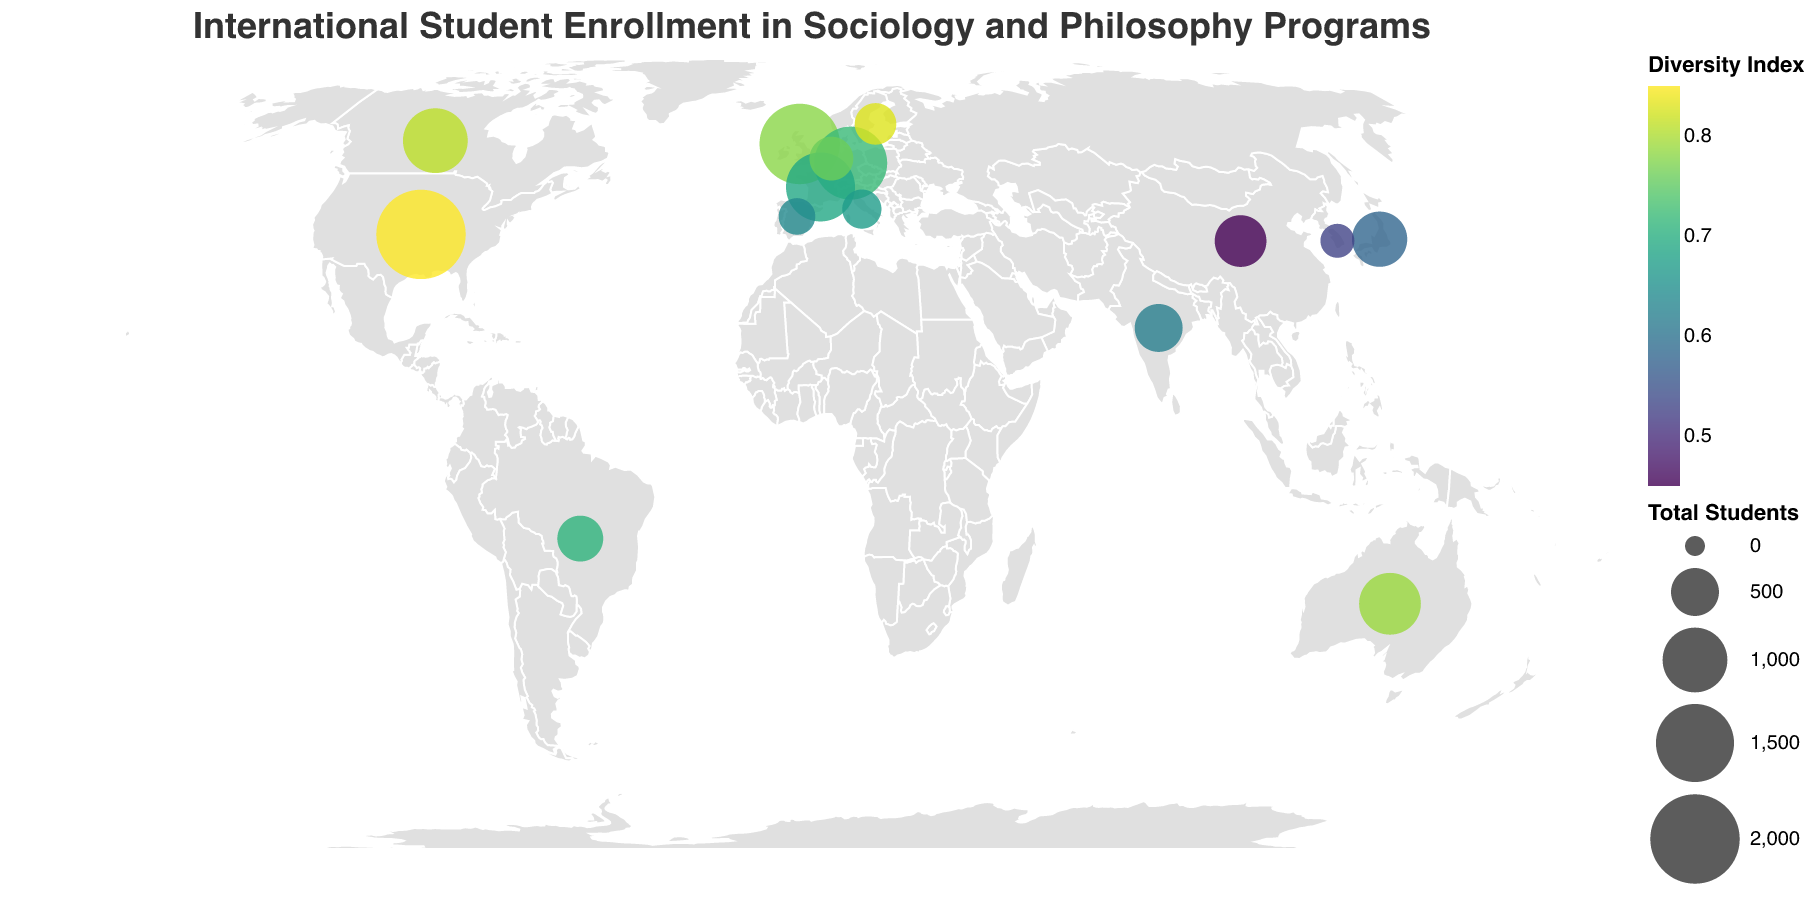What is the title of the figure? The title is usually found at the top of the figure, typically in larger text and sometimes bold. In this case, it reads: "International Student Enrollment in Sociology and Philosophy Programs"
Answer: International Student Enrollment in Sociology and Philosophy Programs Which country has the highest total number of students? To find the country with the highest number of total students, look for the largest circle on the map. The tooltip will help confirm the exact numbers. Here, the largest circle corresponds to the United States with 2000 students.
Answer: United States What is the Diversity Index for Canada? To find this, look for the circle located in Canada. Hover over or refer to the tooltip to find the Diversity Index. The Diversity Index for Canada is provided as 0.81.
Answer: 0.81 Which country has the lowest Diversity Index? To locate the country with the lowest Diversity Index, identify the circle with the color representing the lowest value on the color scale (viridis). From the data, this country is China, with a Diversity Index of 0.45.
Answer: China How many Sociology Students are there in Japan? Look at the circle representing Japan and refer to the tooltip that appears. The number of Sociology Students in Japan is listed as 450.
Answer: 450 Compare the total number of students in the United Kingdom and Germany. Which country has more? By comparing the size of the circles and referring to the tooltips, the United Kingdom has 1600 total students while Germany has 1300. Therefore, the United Kingdom has more students.
Answer: United Kingdom Calculate the average Diversity Index of the countries plotted. First, sum up all the Diversity Index values: 0.85 + 0.78 + 0.72 + 0.69 + 0.81 + 0.79 + 0.58 + 0.45 + 0.62 + 0.71 + 0.76 + 0.83 + 0.67 + 0.64 + 0.53 = 10.63. Since there are 15 countries, the average diversity is found by dividing the sum by 15: 10.63 / 15 = 0.7087.
Answer: 0.71 Which continent has the most diversity hotspots (countries with Diversity Index > 0.75)? Identify countries with Diversity Index > 0.75 and count them by continent. The countries are the United States, Canada, Australia, United Kingdom, Netherlands, and Sweden. Most of these are located in North America and Europe. Europe, then North America, has the most diversity hotspots.
Answer: Europe, North America What is the smallest circle on the map, and which country does it represent? The smallest circle corresponds to the country with the lowest total student number. From the data, South Korea has the least number of total students (200), represented by the smallest circle.
Answer: South Korea What is the difference in Diversity Index between the United States and China? The Diversity Index for the United States is 0.85, and for China, it is 0.45. The difference is calculated as 0.85 - 0.45 = 0.40.
Answer: 0.40 